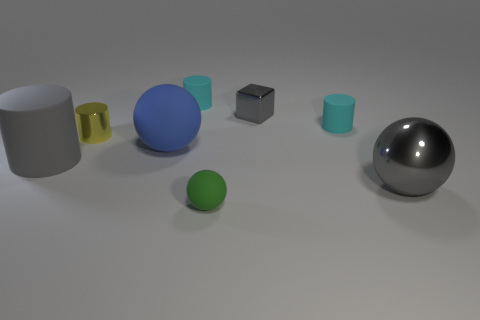Is there any other thing that has the same shape as the tiny green thing?
Ensure brevity in your answer.  Yes. Are there more tiny metallic cubes on the right side of the small metal block than big spheres in front of the gray ball?
Make the answer very short. No. What is the size of the cyan rubber cylinder behind the small cyan cylinder that is in front of the gray thing behind the small yellow cylinder?
Provide a succinct answer. Small. Are the yellow thing and the large gray object that is on the right side of the small yellow cylinder made of the same material?
Keep it short and to the point. Yes. Is the tiny yellow object the same shape as the big blue matte object?
Ensure brevity in your answer.  No. What number of other things are there of the same material as the green sphere
Give a very brief answer. 4. How many small cyan matte objects are the same shape as the gray matte thing?
Your answer should be very brief. 2. What is the color of the object that is both to the right of the tiny gray metal object and to the left of the big gray metallic thing?
Make the answer very short. Cyan. What number of large gray things are there?
Make the answer very short. 2. Do the yellow metallic cylinder and the green matte sphere have the same size?
Your answer should be compact. Yes. 